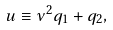<formula> <loc_0><loc_0><loc_500><loc_500>u \equiv \nu ^ { 2 } q _ { 1 } + q _ { 2 } ,</formula> 